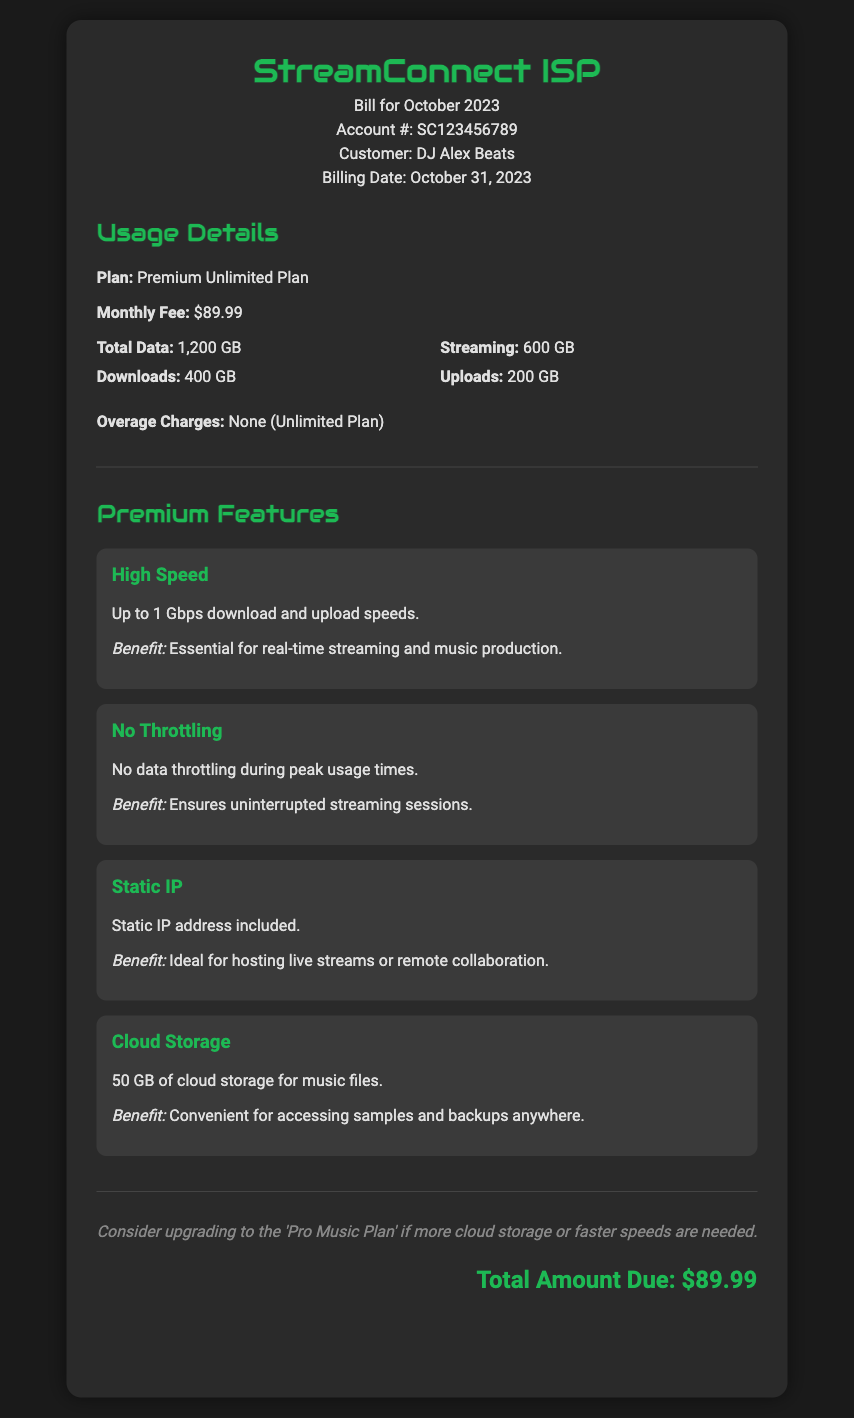What is the billing date? The billing date is listed under the header section of the bill.
Answer: October 31, 2023 What is the monthly fee? The monthly fee is specified in the Usage Details section of the document.
Answer: $89.99 How much total data was used? The total data usage is mentioned in the Usage Details section.
Answer: 1,200 GB What is the amount due? The total amount due is highlighted at the end of the document.
Answer: $89.99 What premium feature benefits real-time streaming and music production? This information is located under the Premium Features section describing one of the features.
Answer: High Speed What is included as part of the plan for music files? The plan details a specific benefit that includes storage.
Answer: 50 GB of cloud storage Is there any overage charge on the plan? The document explicitly states the conditions regarding overage charges.
Answer: None What could be considered for users needing more storage? This suggestion is provided at the end of the bill regarding upgrades.
Answer: Pro Music Plan 